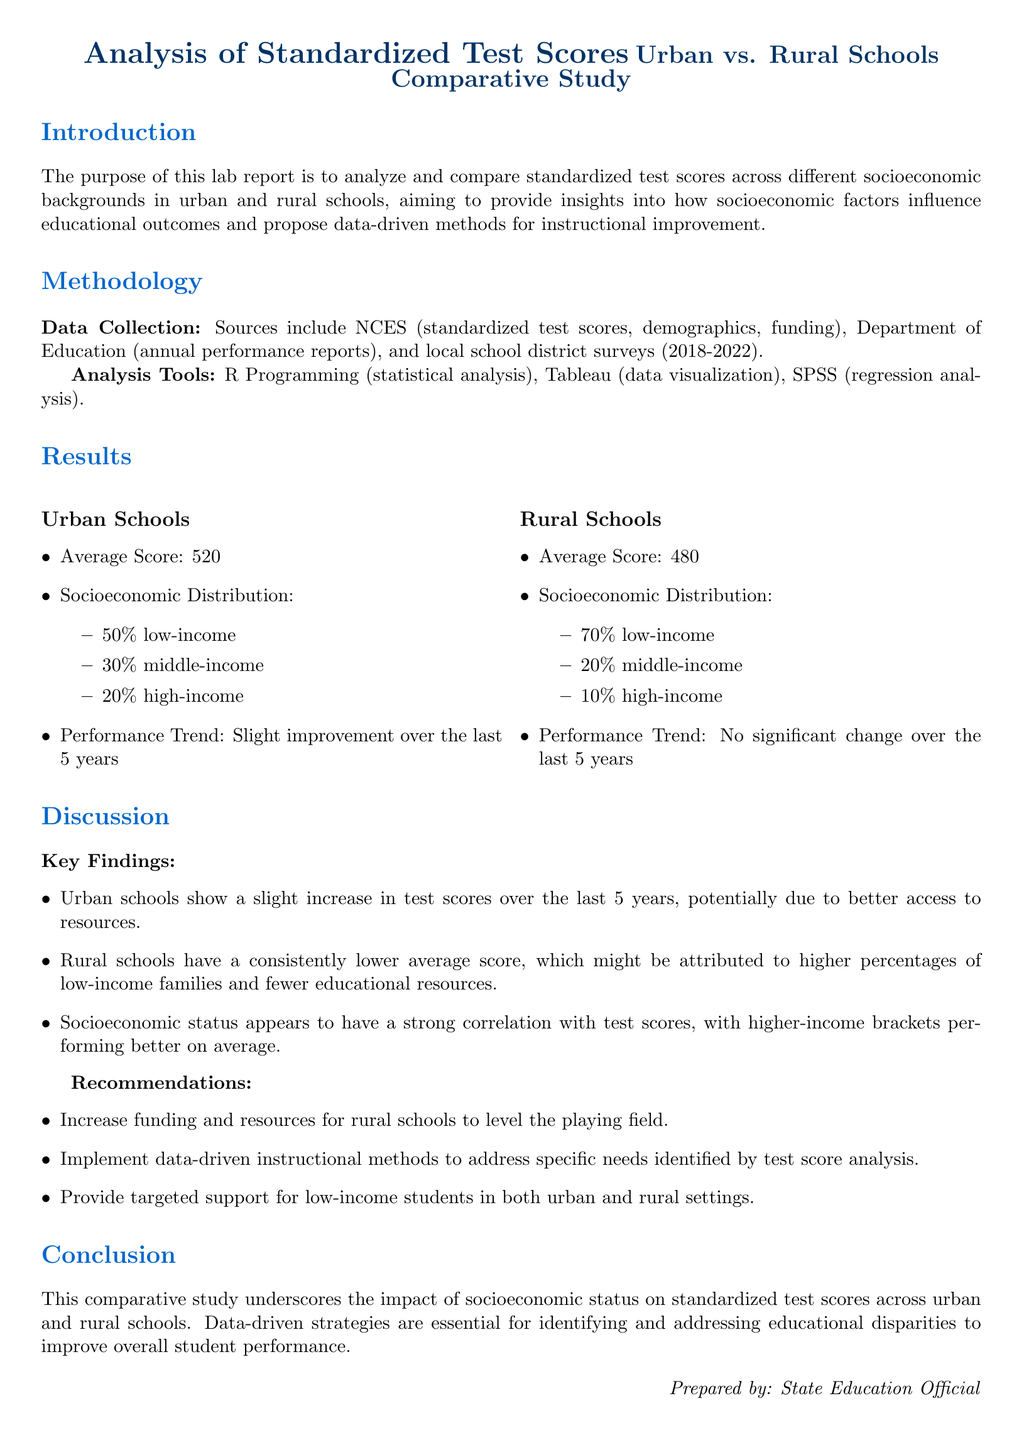what is the average score for urban schools? The average score for urban schools is stated clearly in the results section of the document.
Answer: 520 what is the percentage of low-income students in rural schools? The socioeconomic distribution for rural schools indicates the percentage of low-income students.
Answer: 70% what tool was used for statistical analysis? The methodology section lists the analysis tools used for the study, including the specific tool for statistical analysis.
Answer: R Programming what trend was observed in urban schools over the last 5 years? The results section discusses the performance trend observed in urban schools, specifically noting improvements.
Answer: Slight improvement how does the average score of rural schools compare to urban schools? The results section provides a direct comparison of average scores between the two types of schools.
Answer: Lower what should be increased for rural schools according to the recommendations? The recommendations section outlines specific actions to be taken, including improvements for rural schools.
Answer: Funding what is the main purpose of the lab report? The introduction provides a concise statement on the overall aim of the lab report.
Answer: Analyze and compare standardized test scores what is the impact of socioeconomic status on test scores? The discussion mentions the correlation between socioeconomic status and test scores, summarizing its importance.
Answer: Strong correlation 